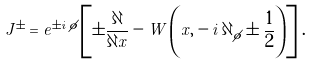<formula> <loc_0><loc_0><loc_500><loc_500>J ^ { \pm } = e ^ { \pm i \, \phi } \left [ \pm \frac { \partial } { \partial x } - W \left ( x , - i \, \partial _ { \phi } \pm \frac { 1 } { 2 } \right ) \right ] \, .</formula> 